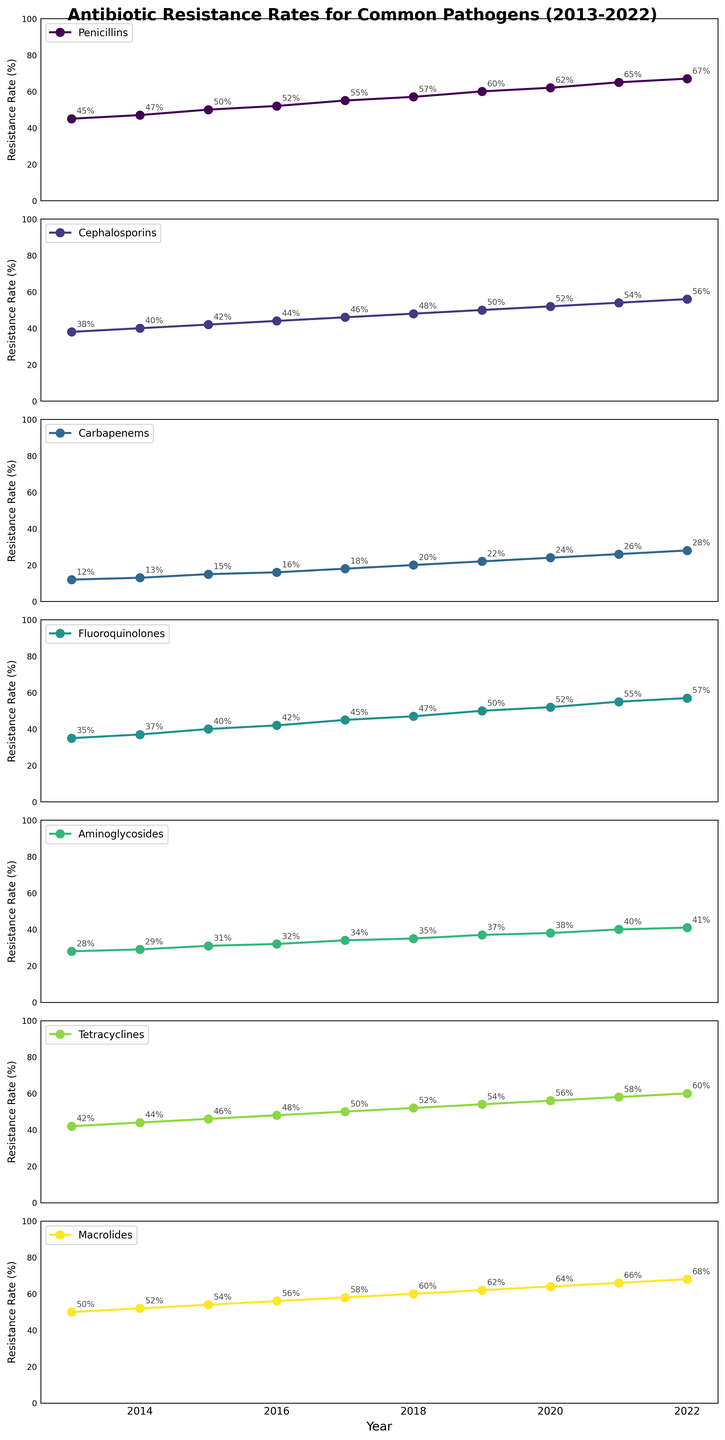What's the average resistance rate for Penicillins over the decade? First, sum the resistance rates for Penicillins from 2013 to 2022: 45 + 47 + 50 + 52 + 55 + 57 + 60 + 62 + 65 + 67. This gives a total of 560. Then divide by the number of years (10): 560 / 10 = 56.
Answer: 56 Which drug class had the highest resistance rate in 2022? Refer to the last year's data (2022) and identify the highest value among all drug classes. The values are: Penicillins: 67%, Cephalosporins: 56%, Carbapenems: 28%, Fluoroquinolones: 57%, Aminoglycosides: 41%, Tetracyclines: 60%, Macrolides: 68%. The highest value is 68% for Macrolides.
Answer: Macrolides How did the resistance rate for Tetracyclines change from 2013 to 2022? Compare the values for Tetracyclines in 2013 (42%) and 2022 (60%). The change is calculated as 60% - 42% = 18%. So, the resistance rate increased by 18%.
Answer: 18% increase Which drug class showed the smallest increase in resistance rates from 2013 to 2022? Calculate the increase for each drug class: 
- Penicillins: 67 - 45 = 22 
- Cephalosporins: 56 - 38 = 18 
- Carbapenems: 28 - 12 = 16 
- Fluoroquinolones: 57 - 35 = 22 
- Aminoglycosides: 41 - 28 = 13 
- Tetracyclines: 60 - 42 = 18 
- Macrolides: 68 - 50 = 18 
The smallest increase is 13% for Aminoglycosides.
Answer: Aminoglycosides Which year had the largest increase in resistance rate for Fluoroquinolones compared to the previous year? Calculate the year-to-year increase for Fluoroquinolones: 
- 2014: 37 - 35 = 2 
- 2015: 40 - 37 = 3 
- 2016: 42 - 40 = 2 
- 2017: 45 - 42 = 3 
- 2018: 47 - 45 = 2 
- 2019: 50 - 47 = 3 
- 2020: 52 - 50 = 2 
- 2021: 55 - 52 = 3 
- 2022: 57 - 55 = 2 
The largest increase is 3%, occurring in 2015, 2017, 2019, and 2021.
Answer: 2015, 2017, 2019, 2021 Which drug class showed no decrease in resistance rate for any year from 2013 to 2022? Check if there is any year for each drug class where the resistance rate decreased compared to the previous year. After evaluating each, it is clear that none of the drug classes show a decrease in resistance rate during this period.
Answer: None What was the rate of increase for resistance to Macrolides from 2018 to 2019? Compare the resistance rate for Macrolides between 2018 (60%) and 2019 (62%). The rate of increase is calculated as (62 - 60) / 60 * 100% = 3.33%.
Answer: 3.33% How much higher was the resistance rate for Penicillins compared to Carbapenems in 2020? Compare the resistance rates for Penicillins (62%) and Carbapenems (24%) in 2020. The difference is 62% - 24% = 38%.
Answer: 38% On average, how much did the resistance rate for Cephalosporins increase each year? Calculate the total increase in resistance rate for Cephalosporins from 2013 (38%) to 2022 (56%): 56% - 38% = 18%. Then divide by the number of years (10): 18 / 10 = 1.8%.
Answer: 1.8% per year In which year did the resistance rate for Aminoglycosides reach 40%? Identify the year where the resistance rate for Aminoglycosides is 40%. It happened in 2021.
Answer: 2021 